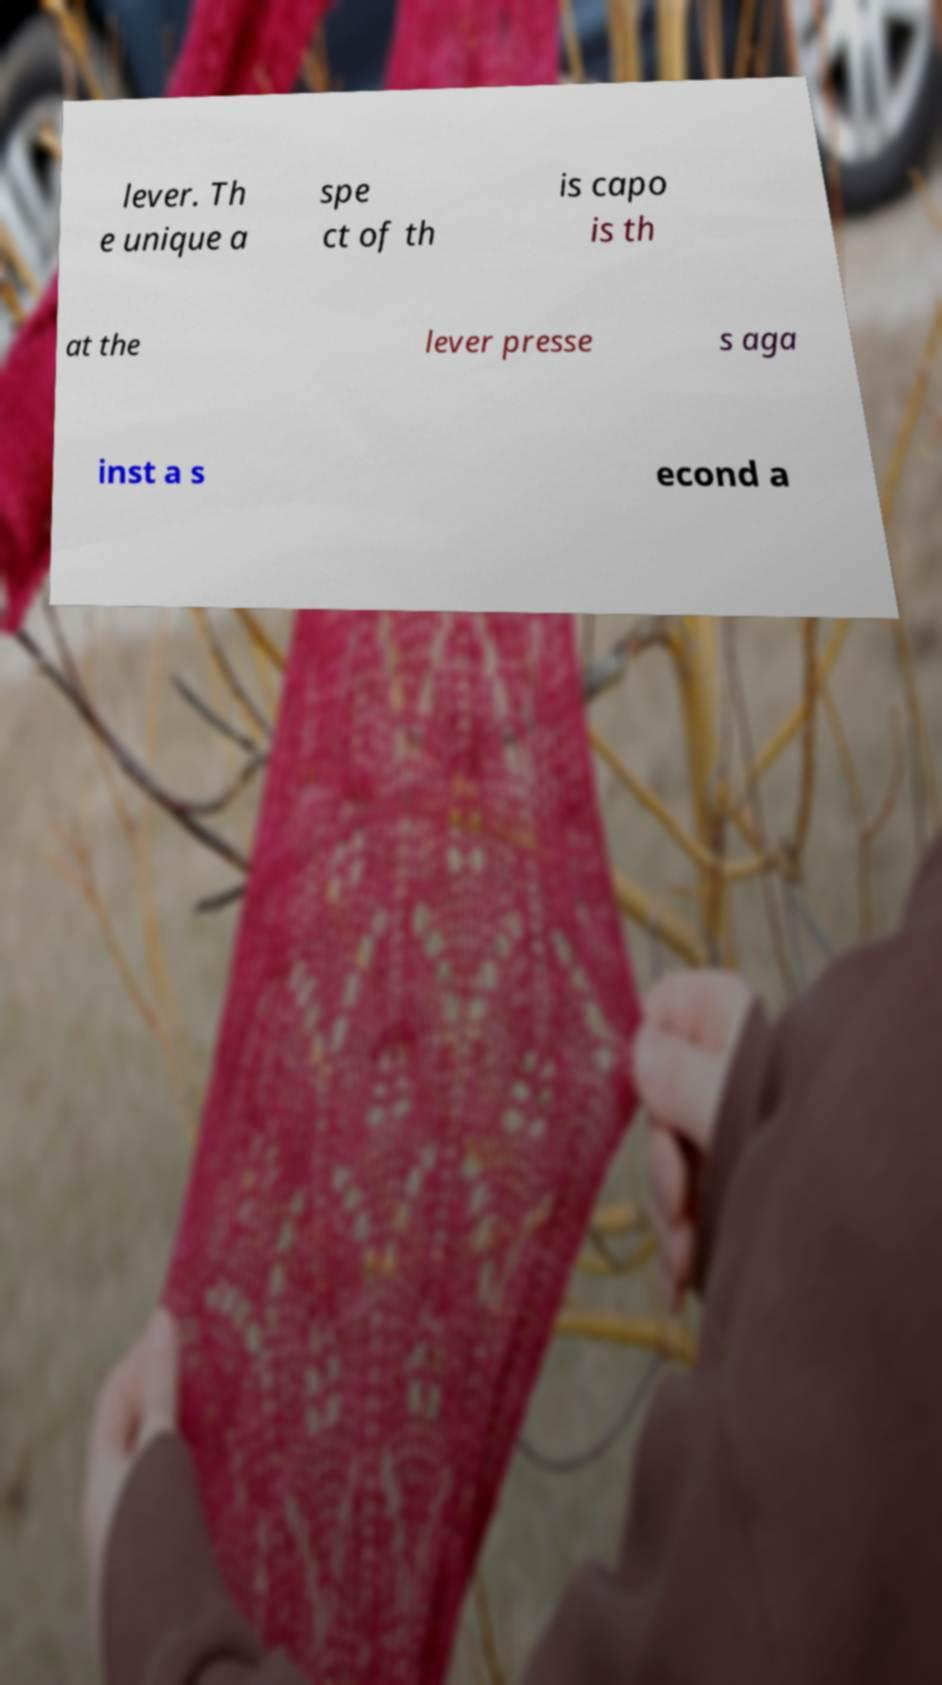Can you accurately transcribe the text from the provided image for me? lever. Th e unique a spe ct of th is capo is th at the lever presse s aga inst a s econd a 